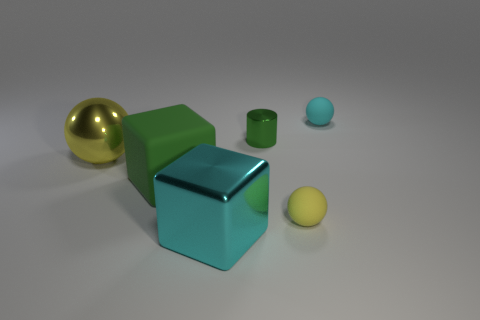Is the size of the shiny object in front of the shiny ball the same as the cyan thing that is behind the shiny sphere?
Your response must be concise. No. There is a yellow object behind the tiny yellow thing; what number of tiny things are left of it?
Ensure brevity in your answer.  0. What is the small green cylinder made of?
Make the answer very short. Metal. How many spheres are in front of the green shiny object?
Your answer should be compact. 2. Is the color of the tiny metal thing the same as the large sphere?
Your answer should be compact. No. How many rubber cubes are the same color as the metallic cylinder?
Offer a very short reply. 1. Is the number of tiny yellow objects greater than the number of large brown rubber cylinders?
Keep it short and to the point. Yes. What size is the object that is both in front of the large rubber object and left of the small yellow sphere?
Keep it short and to the point. Large. Is the material of the yellow ball to the left of the tiny green metallic thing the same as the green thing to the right of the big shiny cube?
Make the answer very short. Yes. What shape is the cyan object that is the same size as the cylinder?
Your answer should be very brief. Sphere. 